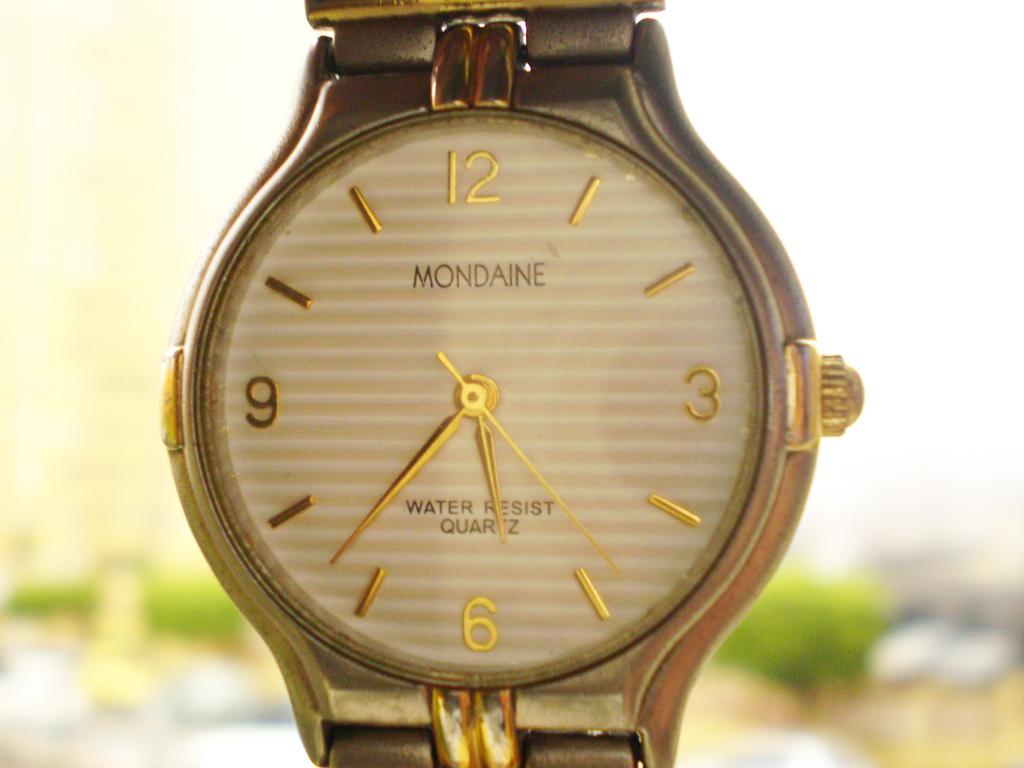Who makes this watch?
Your response must be concise. Mondaine. Is this watch water resistant?
Keep it short and to the point. Yes. 